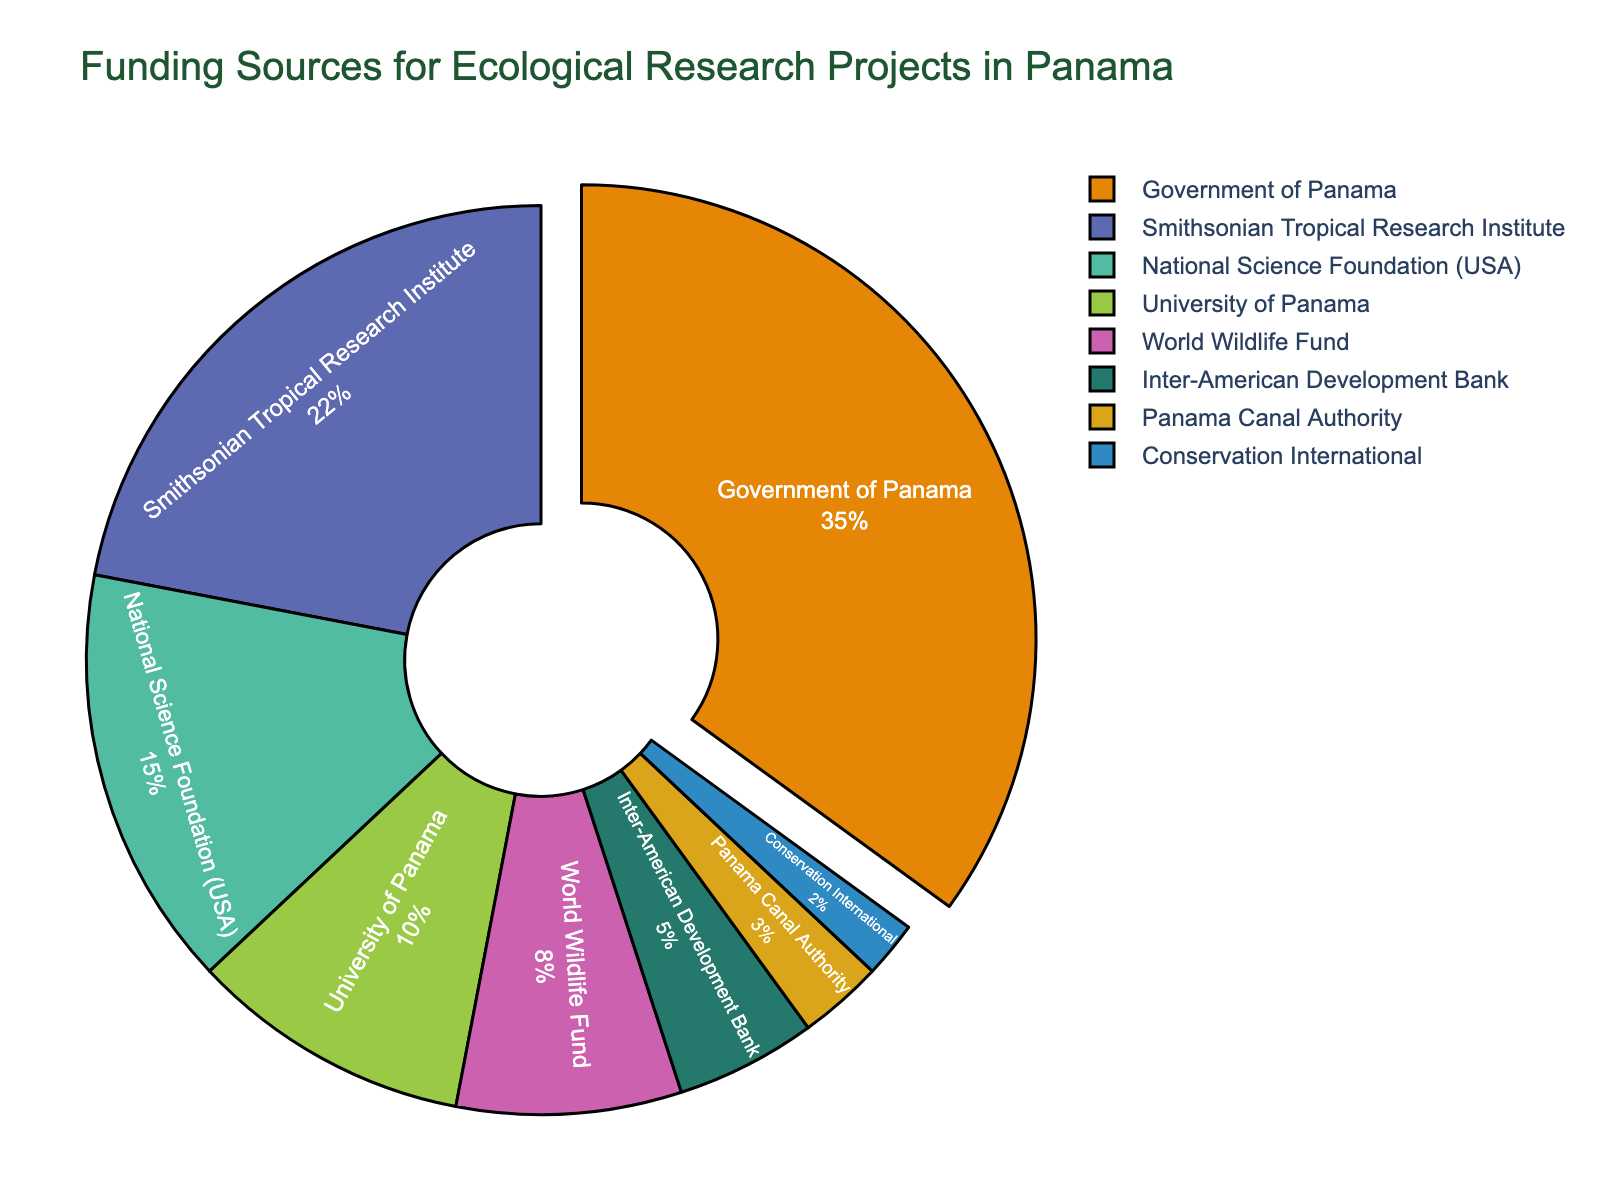Which funding source contributes the smallest percentage? The pie chart shows that Conservation International is the smallest segment.
Answer: Conservation International What is the combined percentage of the Government of Panama and the Smithsonian Tropical Research Institute? The Government of Panama and the Smithsonian Tropical Research Institute percentages are 35% and 22%, respectively. Adding them together: 35% + 22% = 57%.
Answer: 57% Which funding source contributes more: National Science Foundation (USA) or the World Wildlife Fund? Comparing the National Science Foundation (USA) with 15% and the World Wildlife Fund with 8%, the National Science Foundation (USA) contributes more.
Answer: National Science Foundation (USA) What is the difference in percentage points between the University of Panama and the Panama Canal Authority? The percentages for the University of Panama and the Panama Canal Authority are 10% and 3%, respectively. The difference is calculated as 10% - 3% = 7%.
Answer: 7% How many funding sources contribute more than 10%? Reviewing the pie chart, the Government of Panama (35%), Smithsonian Tropical Research Institute (22%), and National Science Foundation (USA) (15%) contribute more than 10%. There are 3 such sources.
Answer: 3 Which funding source is represented by the largest segment in the pie chart? The largest segment in the pie chart is for the Government of Panama, which has the highest percentage (35%).
Answer: Government of Panama What percentage do the World Wildlife Fund and Conservation International contribute together? Adding the percentages of the World Wildlife Fund and Conservation International: 8% + 2% = 10%.
Answer: 10% Which has a larger share: Inter-American Development Bank or the Panama Canal Authority? The Inter-American Development Bank has a share of 5%, while the Panama Canal Authority has a share of 3%. Therefore, the Inter-American Development Bank has a larger share.
Answer: Inter-American Development Bank What is the average percentage contribution of all the funding sources shown? To find the average, add all the percentages: 35% + 22% + 15% + 10% + 8% + 5% + 3% + 2% = 100%. Then divide by the number of sources (8): 100% / 8 = 12.5%.
Answer: 12.5% What is the total percentage contribution of all funding sources other than the Government of Panama? Subtract the percentage of the Government of Panama from the total (100%): 100% - 35% = 65%.
Answer: 65% 